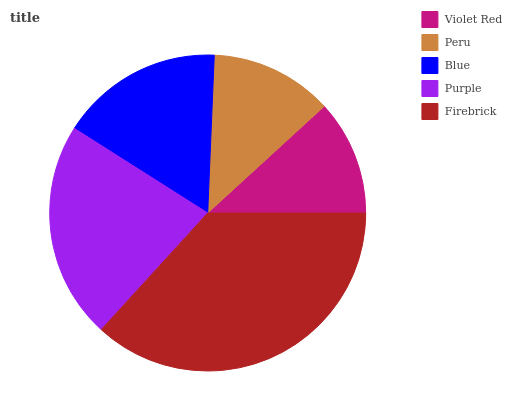Is Violet Red the minimum?
Answer yes or no. Yes. Is Firebrick the maximum?
Answer yes or no. Yes. Is Peru the minimum?
Answer yes or no. No. Is Peru the maximum?
Answer yes or no. No. Is Peru greater than Violet Red?
Answer yes or no. Yes. Is Violet Red less than Peru?
Answer yes or no. Yes. Is Violet Red greater than Peru?
Answer yes or no. No. Is Peru less than Violet Red?
Answer yes or no. No. Is Blue the high median?
Answer yes or no. Yes. Is Blue the low median?
Answer yes or no. Yes. Is Purple the high median?
Answer yes or no. No. Is Peru the low median?
Answer yes or no. No. 